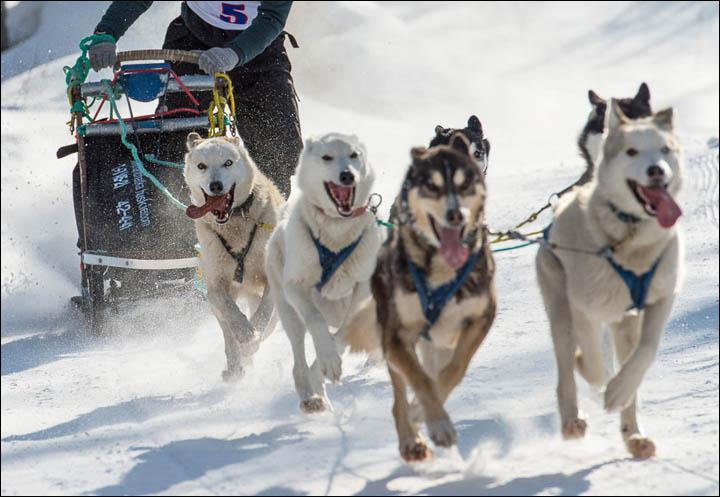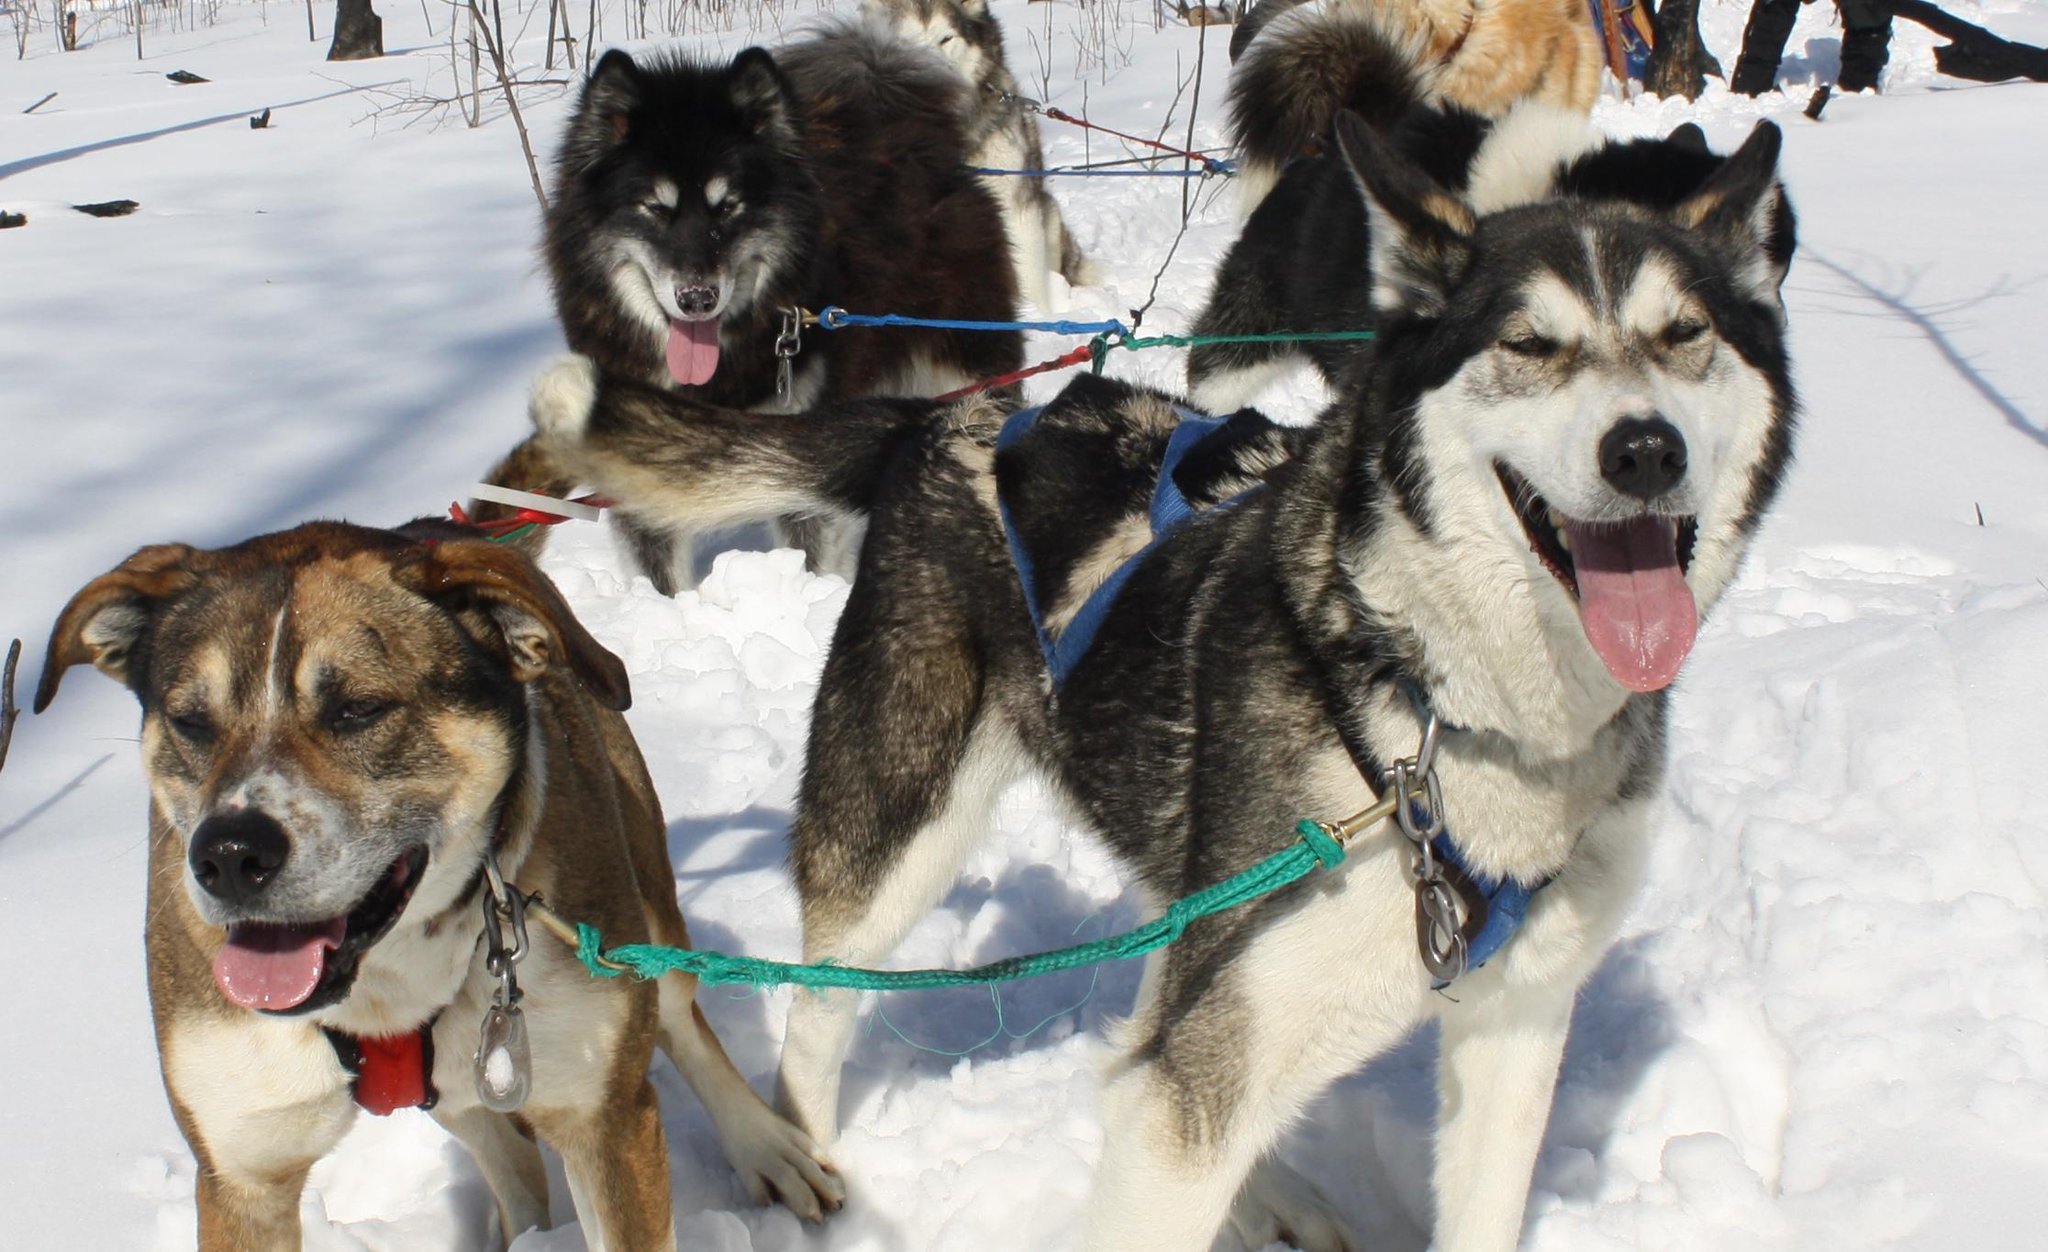The first image is the image on the left, the second image is the image on the right. Assess this claim about the two images: "None of the harnessed dogs in one image are typical husky-type sled dogs.". Correct or not? Answer yes or no. No. The first image is the image on the left, the second image is the image on the right. Examine the images to the left and right. Is the description "In one image, a team of dogs is pulling a sled on which a person is standing, while a second image shows a team of dogs up close, standing in their harnesses." accurate? Answer yes or no. Yes. 